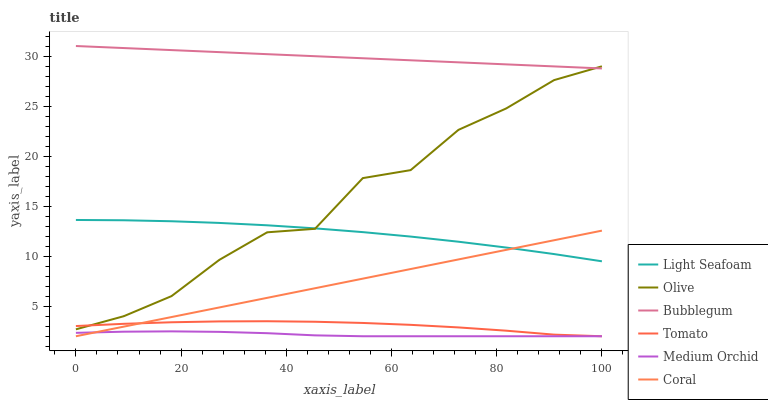Does Coral have the minimum area under the curve?
Answer yes or no. No. Does Coral have the maximum area under the curve?
Answer yes or no. No. Is Coral the smoothest?
Answer yes or no. No. Is Coral the roughest?
Answer yes or no. No. Does Bubblegum have the lowest value?
Answer yes or no. No. Does Coral have the highest value?
Answer yes or no. No. Is Light Seafoam less than Bubblegum?
Answer yes or no. Yes. Is Bubblegum greater than Tomato?
Answer yes or no. Yes. Does Light Seafoam intersect Bubblegum?
Answer yes or no. No. 